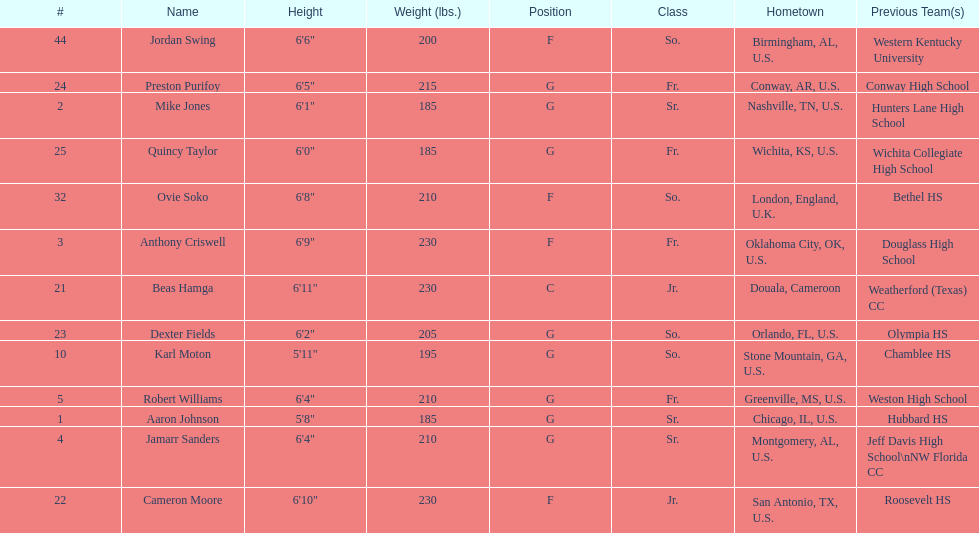Who is first on the roster? Aaron Johnson. 